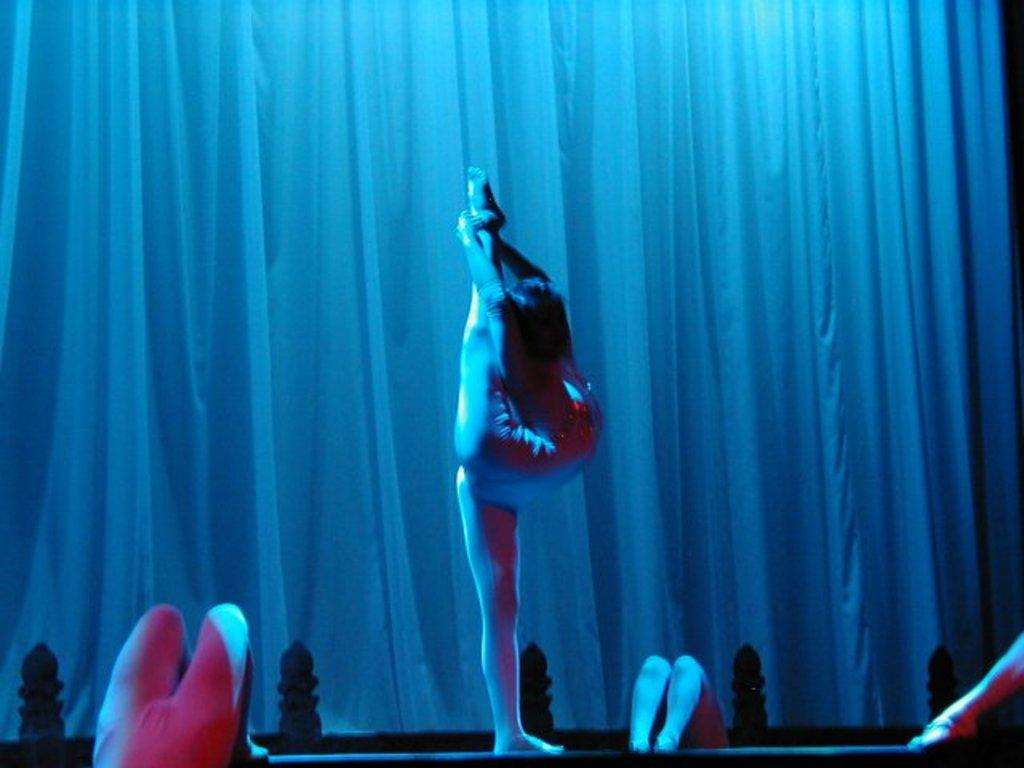What activity are the people in the image engaged in? The people in the image are performing gymnastics. What can be seen in the background of the image? There is a curtain in the background of the image. What type of boat is visible in the image? There is no boat present in the image; it features people performing gymnastics with a curtain in the background. 